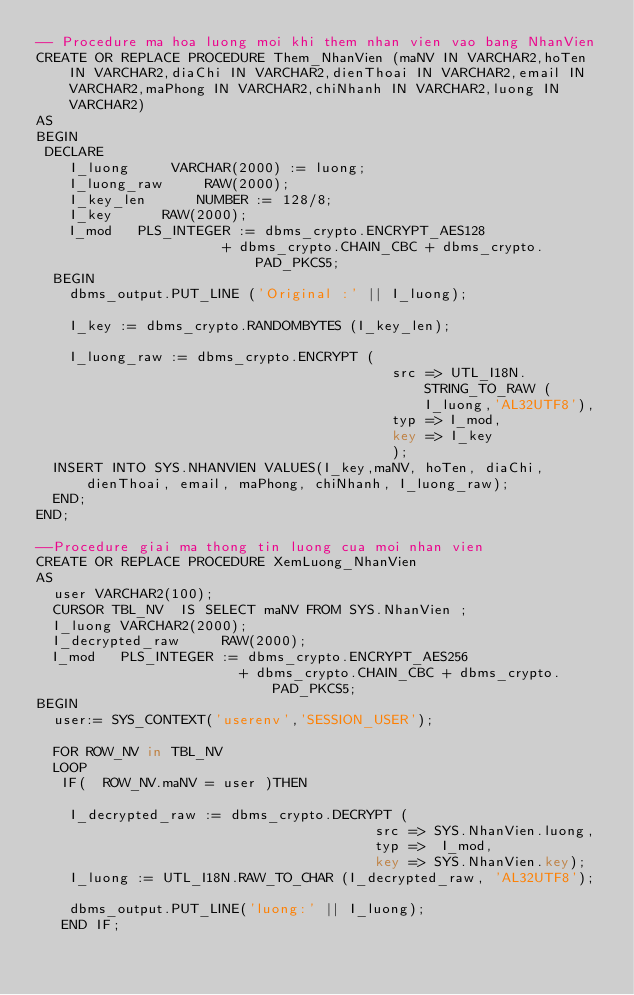Convert code to text. <code><loc_0><loc_0><loc_500><loc_500><_SQL_>-- Procedure ma hoa luong moi khi them nhan vien vao bang NhanVien
CREATE OR REPLACE PROCEDURE Them_NhanVien (maNV IN VARCHAR2,hoTen IN VARCHAR2,diaChi IN VARCHAR2,dienThoai IN VARCHAR2,email IN VARCHAR2,maPhong IN VARCHAR2,chiNhanh IN VARCHAR2,luong IN VARCHAR2) 
AS 
BEGIN
 DECLARE
    I_luong     VARCHAR(2000) := luong;
    I_luong_raw     RAW(2000);
    I_key_len      NUMBER := 128/8;
    I_key      RAW(2000);
    I_mod   PLS_INTEGER := dbms_crypto.ENCRYPT_AES128
                      + dbms_crypto.CHAIN_CBC + dbms_crypto.PAD_PKCS5;
  BEGIN
    dbms_output.PUT_LINE ('Original :' || I_luong);
    
    I_key := dbms_crypto.RANDOMBYTES (I_key_len);
    
    I_luong_raw := dbms_crypto.ENCRYPT (
                                          src => UTL_I18N.STRING_TO_RAW (I_luong,'AL32UTF8'),
                                          typ => I_mod,
                                          key => I_key
                                          );
  INSERT INTO SYS.NHANVIEN VALUES(I_key,maNV, hoTen, diaChi, dienThoai, email, maPhong, chiNhanh, I_luong_raw);
  END;
END;

--Procedure giai ma thong tin luong cua moi nhan vien
CREATE OR REPLACE PROCEDURE XemLuong_NhanVien
AS
  user VARCHAR2(100);
  CURSOR TBL_NV  IS SELECT maNV FROM SYS.NhanVien ;
  I_luong VARCHAR2(2000);
  I_decrypted_raw     RAW(2000); 
  I_mod   PLS_INTEGER := dbms_crypto.ENCRYPT_AES256
                        + dbms_crypto.CHAIN_CBC + dbms_crypto.PAD_PKCS5;                                                     
BEGIN
  user:= SYS_CONTEXT('userenv','SESSION_USER');
  
  FOR ROW_NV in TBL_NV
  LOOP  
   IF(  ROW_NV.maNV = user )THEN
  
    I_decrypted_raw := dbms_crypto.DECRYPT (
                                        src => SYS.NhanVien.luong,
                                        typ =>  I_mod,
                                        key => SYS.NhanVien.key);                                   
    I_luong := UTL_I18N.RAW_TO_CHAR (I_decrypted_raw, 'AL32UTF8');
    
    dbms_output.PUT_LINE('luong:' || I_luong);
   END IF;</code> 